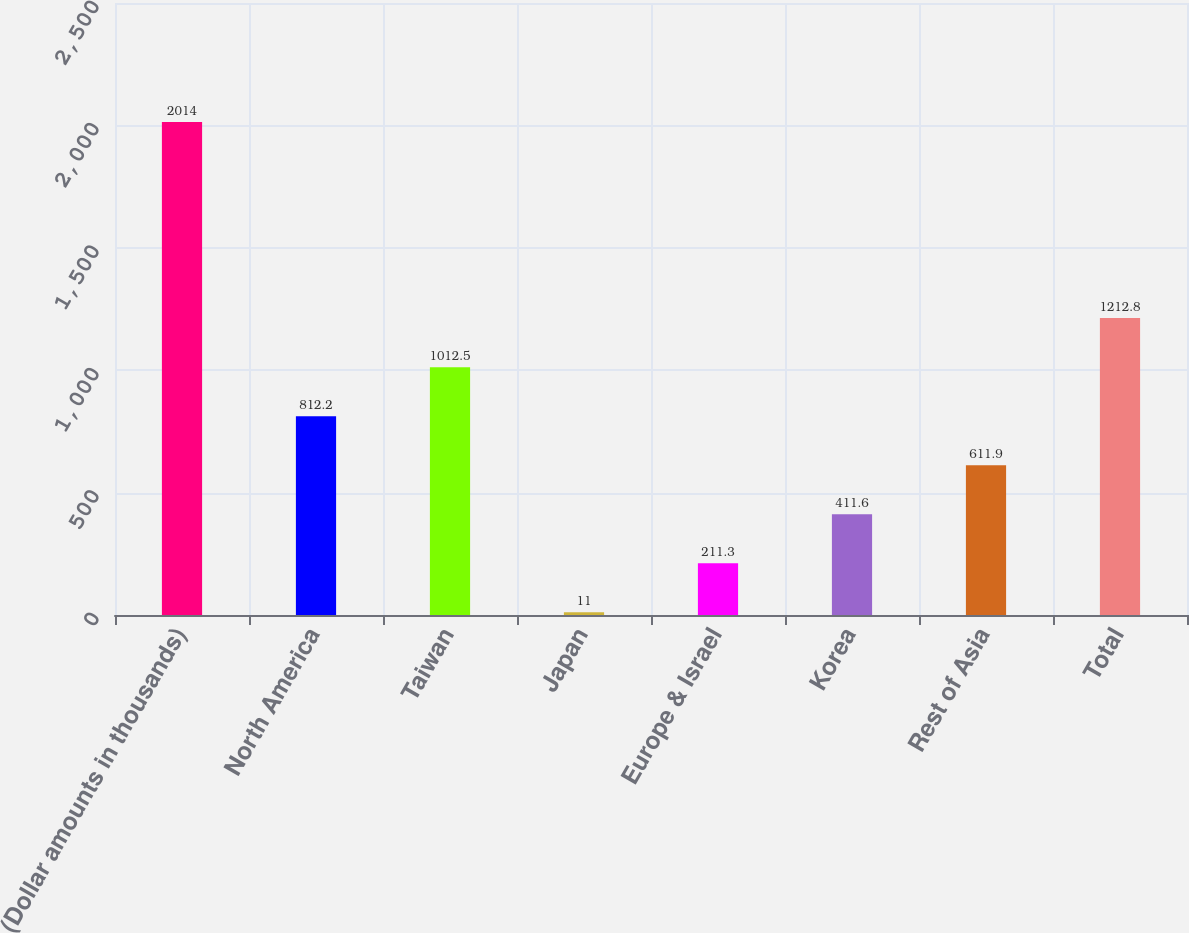<chart> <loc_0><loc_0><loc_500><loc_500><bar_chart><fcel>(Dollar amounts in thousands)<fcel>North America<fcel>Taiwan<fcel>Japan<fcel>Europe & Israel<fcel>Korea<fcel>Rest of Asia<fcel>Total<nl><fcel>2014<fcel>812.2<fcel>1012.5<fcel>11<fcel>211.3<fcel>411.6<fcel>611.9<fcel>1212.8<nl></chart> 